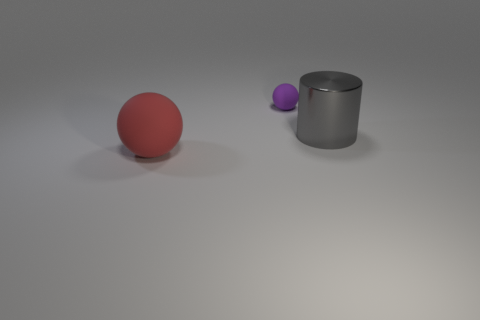Is the shape of the thing that is in front of the big metal cylinder the same as the large object that is to the right of the red rubber sphere? no 